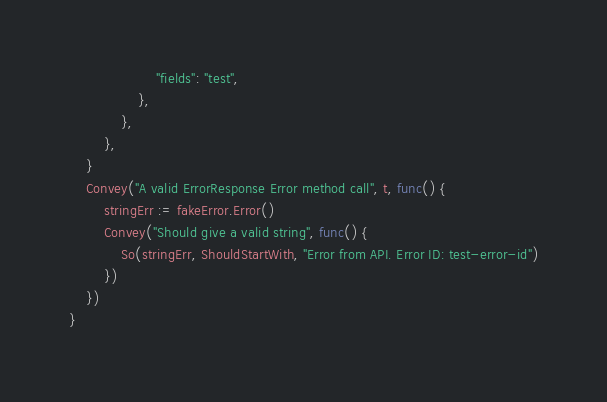Convert code to text. <code><loc_0><loc_0><loc_500><loc_500><_Go_>					"fields": "test",
				},
			},
		},
	}
	Convey("A valid ErrorResponse Error method call", t, func() {
		stringErr := fakeError.Error()
		Convey("Should give a valid string", func() {
			So(stringErr, ShouldStartWith, "Error from API. Error ID: test-error-id")
		})
	})
}
</code> 